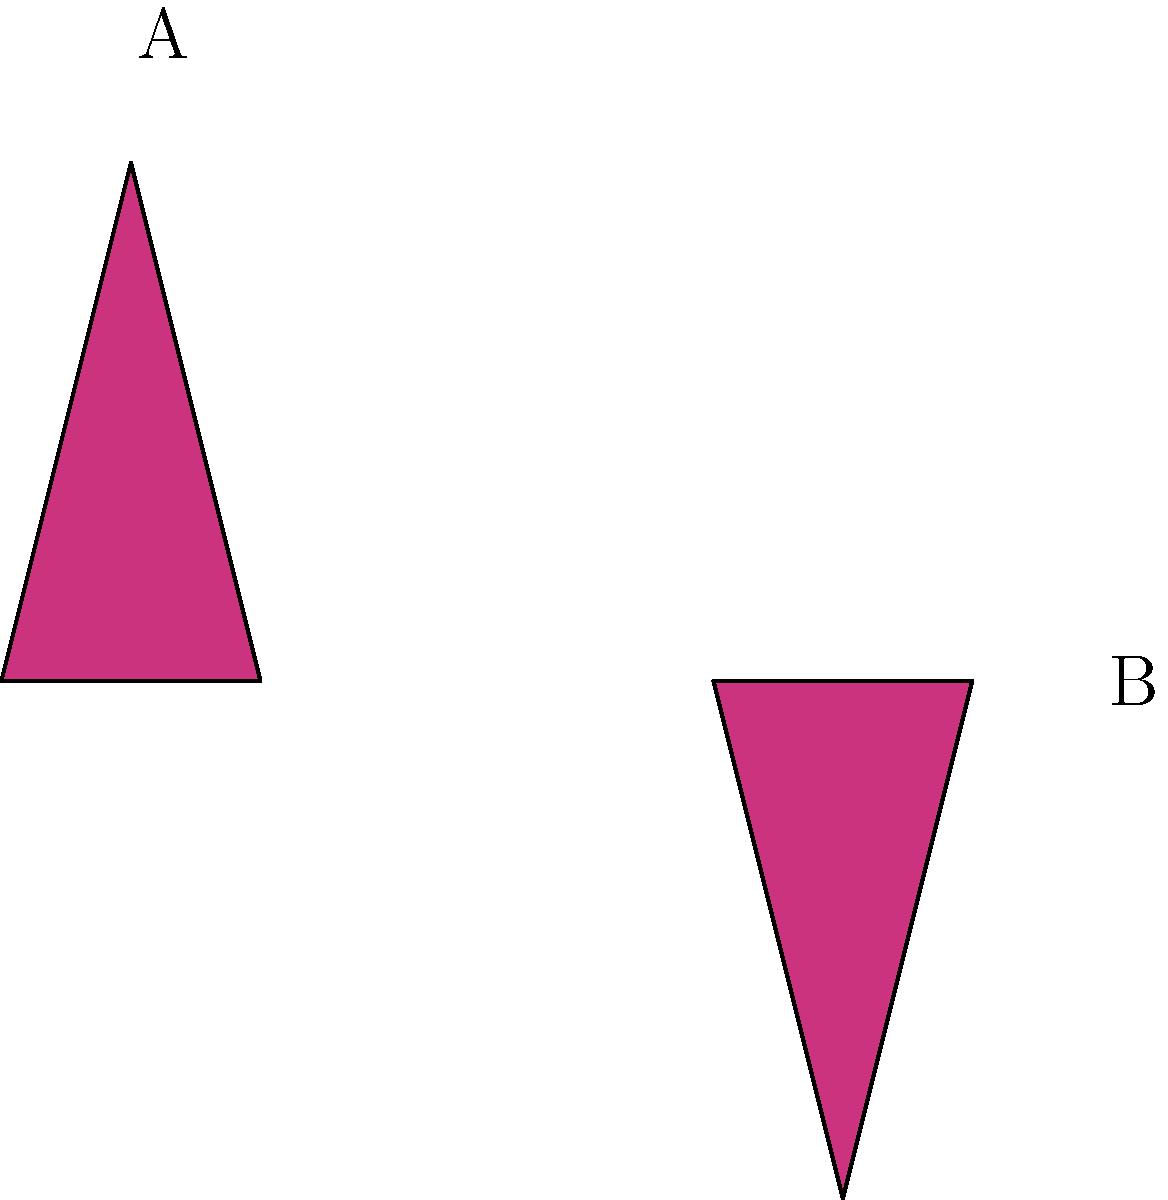In your latest haute couture dress design, you've incorporated two triangular patterns as shown. Are shapes A and B congruent? If so, describe the transformation that maps A onto B. To determine if shapes A and B are congruent, we need to follow these steps:

1. Observe the shapes: Both A and B are triangular and appear to have the same size and shape.

2. Identify the transformation:
   a) Shape B appears to be an upside-down version of shape A.
   b) This suggests a 180-degree rotation.

3. Verify the transformation:
   a) If we rotate shape A by 180 degrees around its center, it would align perfectly with shape B.
   b) This rotation preserves all side lengths and angles, which is a property of congruent shapes.

4. Consider the properties of congruence:
   a) Congruent shapes have equal side lengths and equal angles.
   b) Rotations preserve these properties, so if the shapes match after rotation, they are congruent.

5. Fashion design context:
   In haute couture, symmetry and repetition of patterns are often used to create balance and visual interest. The use of congruent shapes in different orientations is a common technique to achieve this effect.

Therefore, shapes A and B are indeed congruent, and the transformation that maps A onto B is a 180-degree rotation.
Answer: Yes; 180-degree rotation 